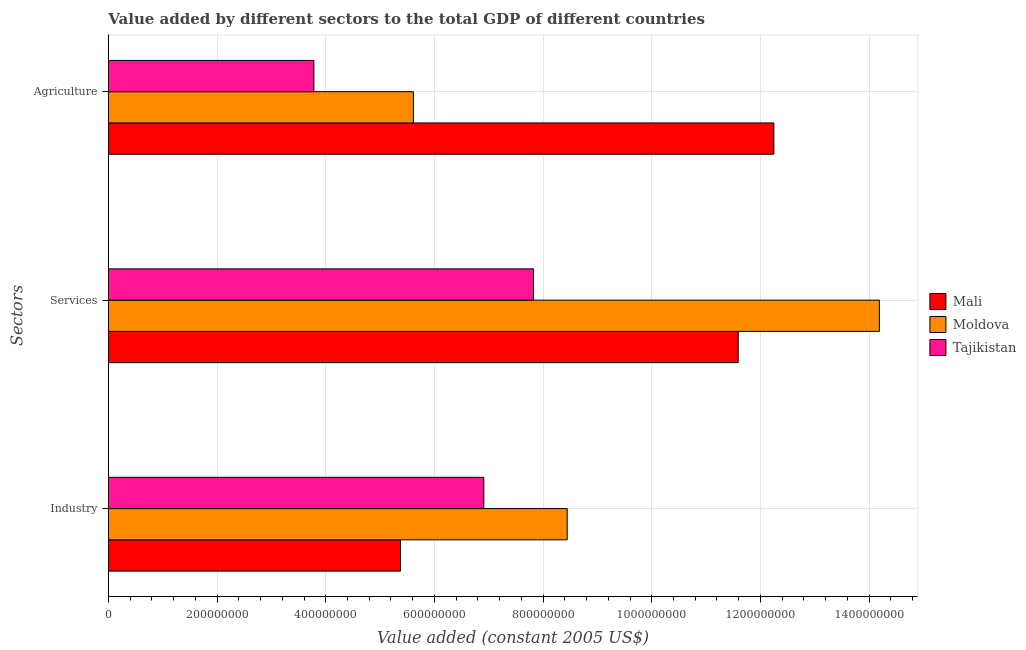How many groups of bars are there?
Your answer should be very brief. 3. Are the number of bars per tick equal to the number of legend labels?
Offer a terse response. Yes. How many bars are there on the 1st tick from the top?
Give a very brief answer. 3. How many bars are there on the 1st tick from the bottom?
Your answer should be very brief. 3. What is the label of the 1st group of bars from the top?
Give a very brief answer. Agriculture. What is the value added by industrial sector in Mali?
Offer a terse response. 5.38e+08. Across all countries, what is the maximum value added by services?
Your answer should be very brief. 1.42e+09. Across all countries, what is the minimum value added by services?
Your answer should be very brief. 7.82e+08. In which country was the value added by agricultural sector maximum?
Provide a short and direct response. Mali. In which country was the value added by industrial sector minimum?
Give a very brief answer. Mali. What is the total value added by services in the graph?
Provide a short and direct response. 3.36e+09. What is the difference between the value added by industrial sector in Moldova and that in Mali?
Make the answer very short. 3.07e+08. What is the difference between the value added by industrial sector in Moldova and the value added by services in Tajikistan?
Provide a succinct answer. 6.20e+07. What is the average value added by industrial sector per country?
Offer a terse response. 6.91e+08. What is the difference between the value added by industrial sector and value added by agricultural sector in Mali?
Your response must be concise. -6.87e+08. What is the ratio of the value added by industrial sector in Mali to that in Moldova?
Give a very brief answer. 0.64. Is the difference between the value added by services in Mali and Tajikistan greater than the difference between the value added by agricultural sector in Mali and Tajikistan?
Your answer should be very brief. No. What is the difference between the highest and the second highest value added by agricultural sector?
Offer a terse response. 6.63e+08. What is the difference between the highest and the lowest value added by agricultural sector?
Offer a very short reply. 8.47e+08. In how many countries, is the value added by industrial sector greater than the average value added by industrial sector taken over all countries?
Your answer should be compact. 1. Is the sum of the value added by industrial sector in Moldova and Tajikistan greater than the maximum value added by services across all countries?
Provide a short and direct response. Yes. What does the 1st bar from the top in Agriculture represents?
Provide a succinct answer. Tajikistan. What does the 3rd bar from the bottom in Agriculture represents?
Provide a short and direct response. Tajikistan. Are all the bars in the graph horizontal?
Keep it short and to the point. Yes. What is the difference between two consecutive major ticks on the X-axis?
Offer a very short reply. 2.00e+08. Does the graph contain any zero values?
Your answer should be compact. No. Does the graph contain grids?
Keep it short and to the point. Yes. Where does the legend appear in the graph?
Your response must be concise. Center right. How are the legend labels stacked?
Your answer should be compact. Vertical. What is the title of the graph?
Provide a short and direct response. Value added by different sectors to the total GDP of different countries. What is the label or title of the X-axis?
Ensure brevity in your answer.  Value added (constant 2005 US$). What is the label or title of the Y-axis?
Your response must be concise. Sectors. What is the Value added (constant 2005 US$) of Mali in Industry?
Offer a very short reply. 5.38e+08. What is the Value added (constant 2005 US$) in Moldova in Industry?
Give a very brief answer. 8.44e+08. What is the Value added (constant 2005 US$) in Tajikistan in Industry?
Offer a terse response. 6.91e+08. What is the Value added (constant 2005 US$) in Mali in Services?
Provide a short and direct response. 1.16e+09. What is the Value added (constant 2005 US$) of Moldova in Services?
Your answer should be compact. 1.42e+09. What is the Value added (constant 2005 US$) in Tajikistan in Services?
Offer a very short reply. 7.82e+08. What is the Value added (constant 2005 US$) of Mali in Agriculture?
Ensure brevity in your answer.  1.22e+09. What is the Value added (constant 2005 US$) in Moldova in Agriculture?
Give a very brief answer. 5.61e+08. What is the Value added (constant 2005 US$) in Tajikistan in Agriculture?
Make the answer very short. 3.78e+08. Across all Sectors, what is the maximum Value added (constant 2005 US$) of Mali?
Offer a very short reply. 1.22e+09. Across all Sectors, what is the maximum Value added (constant 2005 US$) in Moldova?
Your answer should be very brief. 1.42e+09. Across all Sectors, what is the maximum Value added (constant 2005 US$) of Tajikistan?
Provide a succinct answer. 7.82e+08. Across all Sectors, what is the minimum Value added (constant 2005 US$) in Mali?
Provide a short and direct response. 5.38e+08. Across all Sectors, what is the minimum Value added (constant 2005 US$) of Moldova?
Ensure brevity in your answer.  5.61e+08. Across all Sectors, what is the minimum Value added (constant 2005 US$) of Tajikistan?
Your answer should be very brief. 3.78e+08. What is the total Value added (constant 2005 US$) in Mali in the graph?
Your answer should be very brief. 2.92e+09. What is the total Value added (constant 2005 US$) in Moldova in the graph?
Give a very brief answer. 2.82e+09. What is the total Value added (constant 2005 US$) in Tajikistan in the graph?
Your answer should be compact. 1.85e+09. What is the difference between the Value added (constant 2005 US$) in Mali in Industry and that in Services?
Offer a terse response. -6.22e+08. What is the difference between the Value added (constant 2005 US$) of Moldova in Industry and that in Services?
Provide a succinct answer. -5.75e+08. What is the difference between the Value added (constant 2005 US$) in Tajikistan in Industry and that in Services?
Ensure brevity in your answer.  -9.14e+07. What is the difference between the Value added (constant 2005 US$) of Mali in Industry and that in Agriculture?
Provide a succinct answer. -6.87e+08. What is the difference between the Value added (constant 2005 US$) in Moldova in Industry and that in Agriculture?
Provide a short and direct response. 2.83e+08. What is the difference between the Value added (constant 2005 US$) in Tajikistan in Industry and that in Agriculture?
Provide a short and direct response. 3.13e+08. What is the difference between the Value added (constant 2005 US$) of Mali in Services and that in Agriculture?
Your answer should be very brief. -6.56e+07. What is the difference between the Value added (constant 2005 US$) in Moldova in Services and that in Agriculture?
Your answer should be compact. 8.58e+08. What is the difference between the Value added (constant 2005 US$) in Tajikistan in Services and that in Agriculture?
Your answer should be compact. 4.04e+08. What is the difference between the Value added (constant 2005 US$) in Mali in Industry and the Value added (constant 2005 US$) in Moldova in Services?
Give a very brief answer. -8.81e+08. What is the difference between the Value added (constant 2005 US$) of Mali in Industry and the Value added (constant 2005 US$) of Tajikistan in Services?
Make the answer very short. -2.45e+08. What is the difference between the Value added (constant 2005 US$) in Moldova in Industry and the Value added (constant 2005 US$) in Tajikistan in Services?
Your answer should be compact. 6.20e+07. What is the difference between the Value added (constant 2005 US$) of Mali in Industry and the Value added (constant 2005 US$) of Moldova in Agriculture?
Offer a very short reply. -2.37e+07. What is the difference between the Value added (constant 2005 US$) of Mali in Industry and the Value added (constant 2005 US$) of Tajikistan in Agriculture?
Offer a very short reply. 1.59e+08. What is the difference between the Value added (constant 2005 US$) of Moldova in Industry and the Value added (constant 2005 US$) of Tajikistan in Agriculture?
Your response must be concise. 4.66e+08. What is the difference between the Value added (constant 2005 US$) of Mali in Services and the Value added (constant 2005 US$) of Moldova in Agriculture?
Your answer should be compact. 5.98e+08. What is the difference between the Value added (constant 2005 US$) of Mali in Services and the Value added (constant 2005 US$) of Tajikistan in Agriculture?
Provide a short and direct response. 7.81e+08. What is the difference between the Value added (constant 2005 US$) in Moldova in Services and the Value added (constant 2005 US$) in Tajikistan in Agriculture?
Give a very brief answer. 1.04e+09. What is the average Value added (constant 2005 US$) of Mali per Sectors?
Your response must be concise. 9.74e+08. What is the average Value added (constant 2005 US$) of Moldova per Sectors?
Your response must be concise. 9.42e+08. What is the average Value added (constant 2005 US$) of Tajikistan per Sectors?
Give a very brief answer. 6.17e+08. What is the difference between the Value added (constant 2005 US$) in Mali and Value added (constant 2005 US$) in Moldova in Industry?
Ensure brevity in your answer.  -3.07e+08. What is the difference between the Value added (constant 2005 US$) of Mali and Value added (constant 2005 US$) of Tajikistan in Industry?
Ensure brevity in your answer.  -1.53e+08. What is the difference between the Value added (constant 2005 US$) in Moldova and Value added (constant 2005 US$) in Tajikistan in Industry?
Offer a very short reply. 1.53e+08. What is the difference between the Value added (constant 2005 US$) in Mali and Value added (constant 2005 US$) in Moldova in Services?
Keep it short and to the point. -2.60e+08. What is the difference between the Value added (constant 2005 US$) of Mali and Value added (constant 2005 US$) of Tajikistan in Services?
Keep it short and to the point. 3.77e+08. What is the difference between the Value added (constant 2005 US$) of Moldova and Value added (constant 2005 US$) of Tajikistan in Services?
Make the answer very short. 6.37e+08. What is the difference between the Value added (constant 2005 US$) of Mali and Value added (constant 2005 US$) of Moldova in Agriculture?
Provide a short and direct response. 6.63e+08. What is the difference between the Value added (constant 2005 US$) in Mali and Value added (constant 2005 US$) in Tajikistan in Agriculture?
Provide a short and direct response. 8.47e+08. What is the difference between the Value added (constant 2005 US$) of Moldova and Value added (constant 2005 US$) of Tajikistan in Agriculture?
Your response must be concise. 1.83e+08. What is the ratio of the Value added (constant 2005 US$) of Mali in Industry to that in Services?
Give a very brief answer. 0.46. What is the ratio of the Value added (constant 2005 US$) of Moldova in Industry to that in Services?
Your response must be concise. 0.6. What is the ratio of the Value added (constant 2005 US$) of Tajikistan in Industry to that in Services?
Your response must be concise. 0.88. What is the ratio of the Value added (constant 2005 US$) in Mali in Industry to that in Agriculture?
Your answer should be compact. 0.44. What is the ratio of the Value added (constant 2005 US$) of Moldova in Industry to that in Agriculture?
Ensure brevity in your answer.  1.5. What is the ratio of the Value added (constant 2005 US$) of Tajikistan in Industry to that in Agriculture?
Provide a short and direct response. 1.83. What is the ratio of the Value added (constant 2005 US$) in Mali in Services to that in Agriculture?
Make the answer very short. 0.95. What is the ratio of the Value added (constant 2005 US$) in Moldova in Services to that in Agriculture?
Ensure brevity in your answer.  2.53. What is the ratio of the Value added (constant 2005 US$) of Tajikistan in Services to that in Agriculture?
Keep it short and to the point. 2.07. What is the difference between the highest and the second highest Value added (constant 2005 US$) in Mali?
Provide a short and direct response. 6.56e+07. What is the difference between the highest and the second highest Value added (constant 2005 US$) in Moldova?
Ensure brevity in your answer.  5.75e+08. What is the difference between the highest and the second highest Value added (constant 2005 US$) of Tajikistan?
Your answer should be very brief. 9.14e+07. What is the difference between the highest and the lowest Value added (constant 2005 US$) in Mali?
Provide a short and direct response. 6.87e+08. What is the difference between the highest and the lowest Value added (constant 2005 US$) of Moldova?
Offer a very short reply. 8.58e+08. What is the difference between the highest and the lowest Value added (constant 2005 US$) of Tajikistan?
Keep it short and to the point. 4.04e+08. 